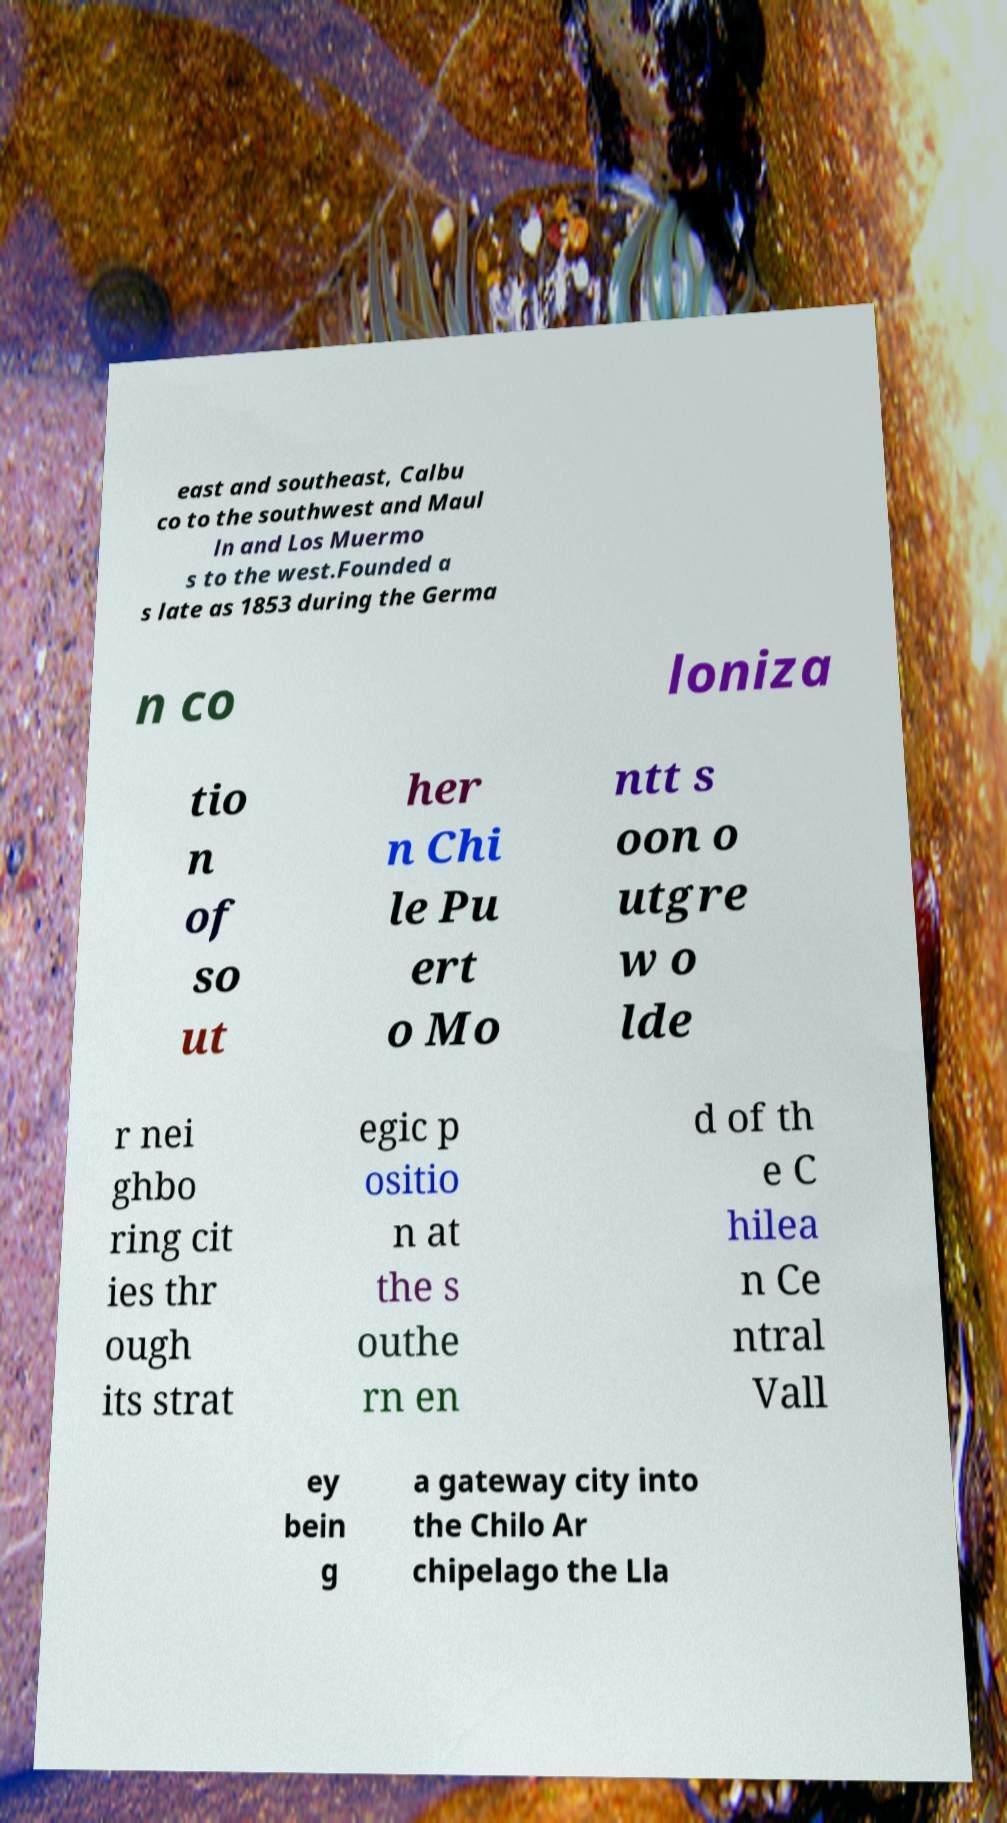There's text embedded in this image that I need extracted. Can you transcribe it verbatim? east and southeast, Calbu co to the southwest and Maul ln and Los Muermo s to the west.Founded a s late as 1853 during the Germa n co loniza tio n of so ut her n Chi le Pu ert o Mo ntt s oon o utgre w o lde r nei ghbo ring cit ies thr ough its strat egic p ositio n at the s outhe rn en d of th e C hilea n Ce ntral Vall ey bein g a gateway city into the Chilo Ar chipelago the Lla 